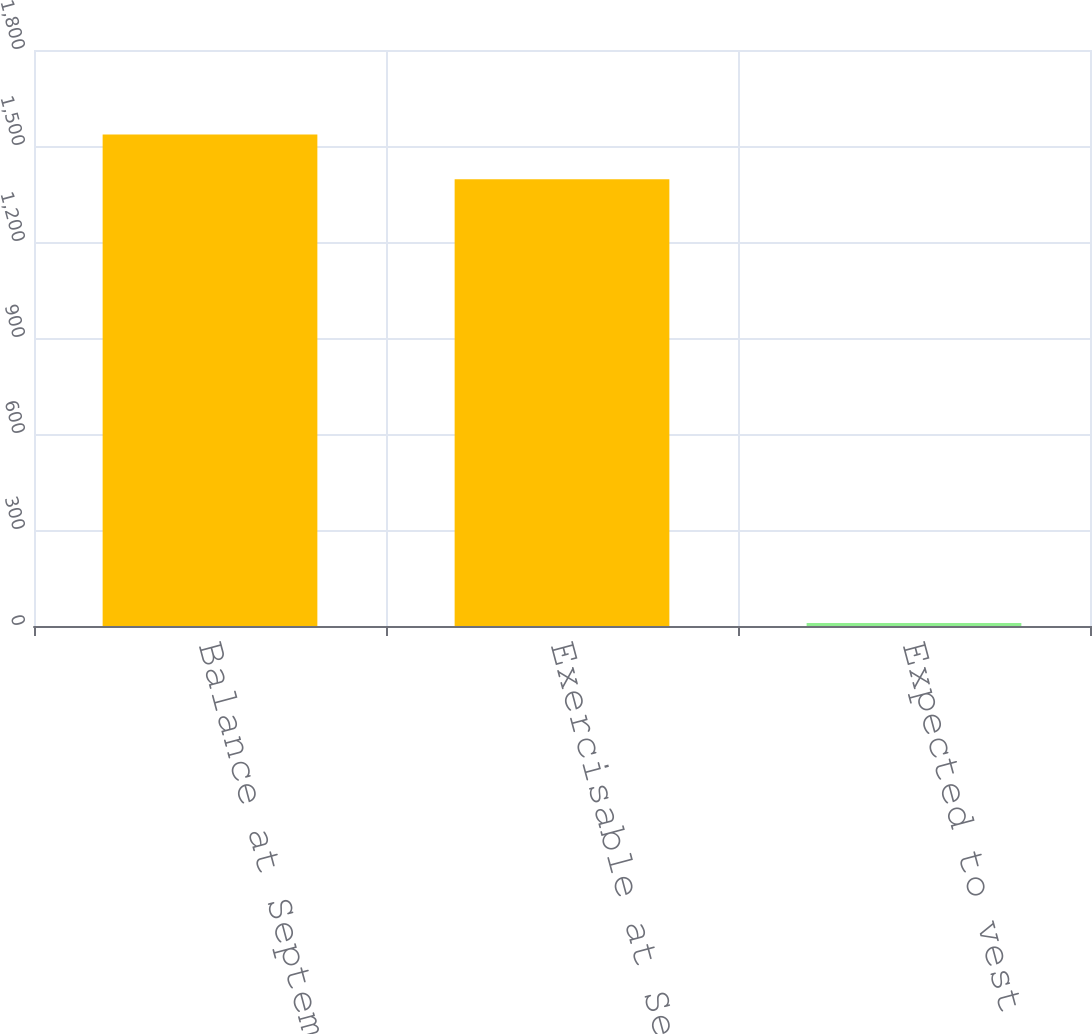<chart> <loc_0><loc_0><loc_500><loc_500><bar_chart><fcel>Balance at September 28 2013<fcel>Exercisable at September 28<fcel>Expected to vest after<nl><fcel>1535.6<fcel>1396<fcel>9<nl></chart> 